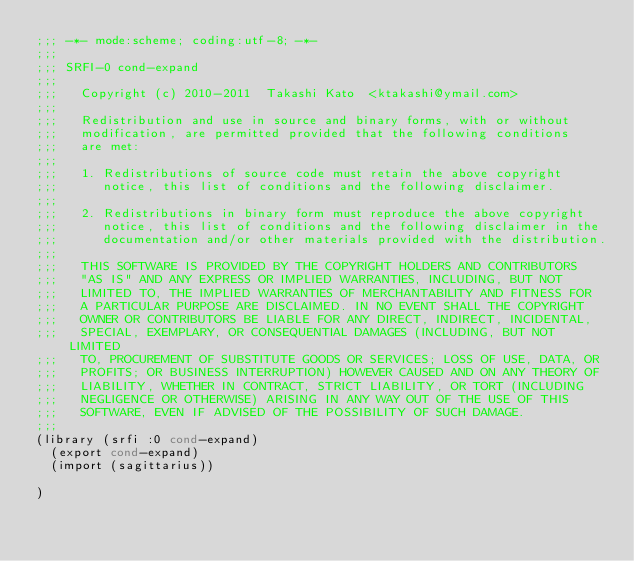Convert code to text. <code><loc_0><loc_0><loc_500><loc_500><_Scheme_>;;; -*- mode:scheme; coding:utf-8; -*-
;;;
;;; SRFI-0 cond-expand
;;;  
;;;   Copyright (c) 2010-2011  Takashi Kato  <ktakashi@ymail.com>
;;;   
;;;   Redistribution and use in source and binary forms, with or without
;;;   modification, are permitted provided that the following conditions
;;;   are met:
;;;   
;;;   1. Redistributions of source code must retain the above copyright
;;;      notice, this list of conditions and the following disclaimer.
;;;  
;;;   2. Redistributions in binary form must reproduce the above copyright
;;;      notice, this list of conditions and the following disclaimer in the
;;;      documentation and/or other materials provided with the distribution.
;;;  
;;;   THIS SOFTWARE IS PROVIDED BY THE COPYRIGHT HOLDERS AND CONTRIBUTORS
;;;   "AS IS" AND ANY EXPRESS OR IMPLIED WARRANTIES, INCLUDING, BUT NOT
;;;   LIMITED TO, THE IMPLIED WARRANTIES OF MERCHANTABILITY AND FITNESS FOR
;;;   A PARTICULAR PURPOSE ARE DISCLAIMED. IN NO EVENT SHALL THE COPYRIGHT
;;;   OWNER OR CONTRIBUTORS BE LIABLE FOR ANY DIRECT, INDIRECT, INCIDENTAL,
;;;   SPECIAL, EXEMPLARY, OR CONSEQUENTIAL DAMAGES (INCLUDING, BUT NOT LIMITED
;;;   TO, PROCUREMENT OF SUBSTITUTE GOODS OR SERVICES; LOSS OF USE, DATA, OR
;;;   PROFITS; OR BUSINESS INTERRUPTION) HOWEVER CAUSED AND ON ANY THEORY OF
;;;   LIABILITY, WHETHER IN CONTRACT, STRICT LIABILITY, OR TORT (INCLUDING
;;;   NEGLIGENCE OR OTHERWISE) ARISING IN ANY WAY OUT OF THE USE OF THIS
;;;   SOFTWARE, EVEN IF ADVISED OF THE POSSIBILITY OF SUCH DAMAGE.
;;;  
(library (srfi :0 cond-expand)
  (export cond-expand)
  (import (sagittarius))

)
</code> 